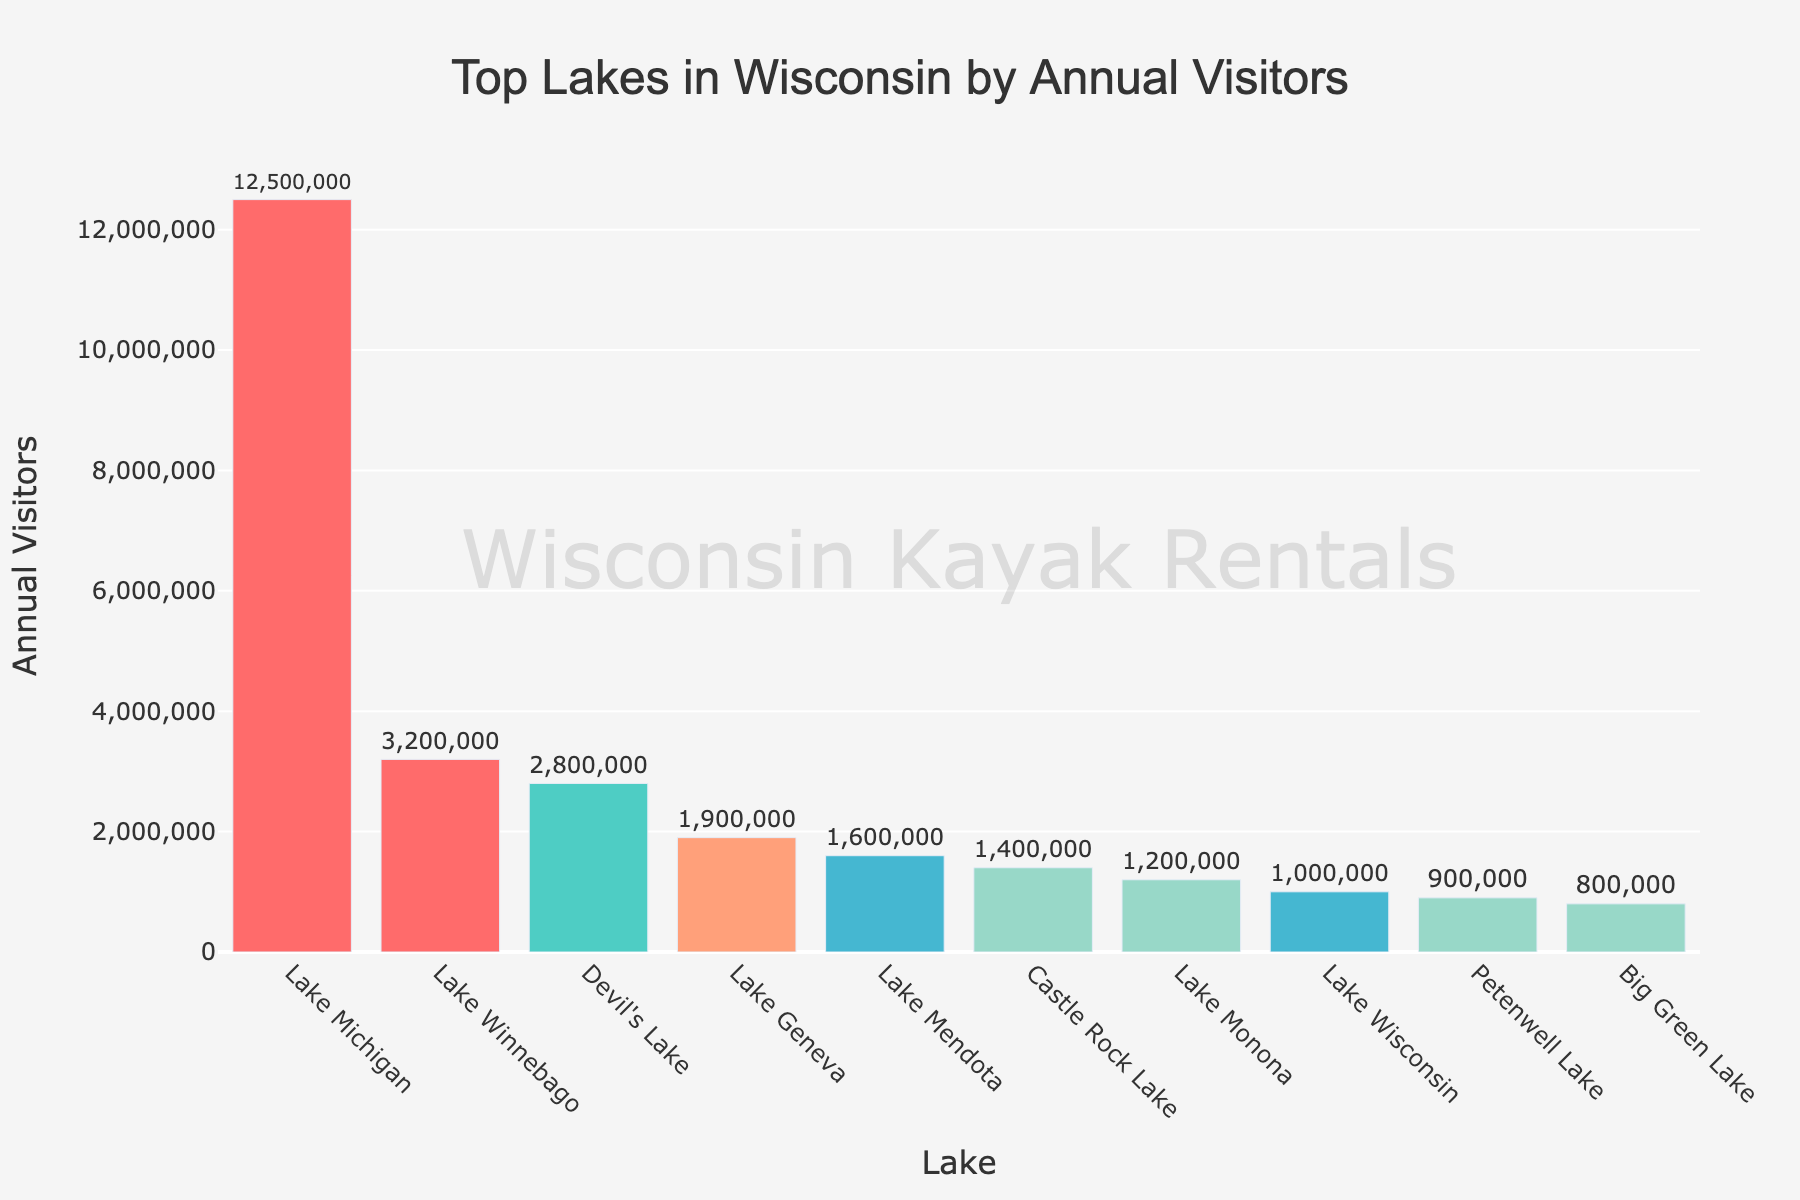Which lake has the highest number of annual visitors? The lake with the highest bar has the greatest number of annual visitors. From the figure, Lake Michigan has the highest bar.
Answer: Lake Michigan Which lake has fewer annual visitors, Lake Mendota or Lake Geneva? Compare the heights of the bars for Lake Mendota and Lake Geneva. Lake Mendota's bar is shorter than Lake Geneva's.
Answer: Lake Mendota What is the combined number of annual visitors for Devil's Lake and Castle Rock Lake? Add the visitor counts for Devil's Lake (2,800,000) and Castle Rock Lake (1,400,000). 2,800,000 + 1,400,000 = 4,200,000.
Answer: 4,200,000 How much more visitors does Lake Winnebago have than Lake Mendota? Subtract the annual visitors of Lake Mendota from Lake Winnebago. Lake Winnebago: 3,200,000, Lake Mendota: 1,600,000. 3,200,000 - 1,600,000 = 1,600,000.
Answer: 1,600,000 Which lake has just over 3 million visitors annually? Look for the bar with an annual visitor count slightly above 3 million. Lake Winnebago has 3,200,000 visitors.
Answer: Lake Winnebago How many visitors do the top three lakes have in total? Add the annual visitors of Lake Michigan, Lake Winnebago, and Devil's Lake. Lake Michigan: 12,500,000, Lake Winnebago: 3,200,000, Devil's Lake: 2,800,000. 12,500,000 + 3,200,000 + 2,800,000 = 18,500,000.
Answer: 18,500,000 Is the number of visitors to Lake Monona more or less than half of Lake Geneva's visitors? Calculate half of Lake Geneva's visitors: 1,900,000 / 2 = 950,000. Compare this with Lake Monona's visitors: 1,200,000. 1,200,000 is more than 950,000.
Answer: More Which lake with over 2 million visitors has the fewest visitors among them? Compare the lakes with above 2 million visitors: Lake Michigan, Lake Winnebago, and Devil's Lake. Devil's Lake has 2,800,000 visitors, which is the fewest among them.
Answer: Devil's Lake Among the lakes listed, which one has just slightly less than 1 million annual visitors? From the bars, Petenwell Lake has 900,000 visitors, slightly less than 1 million.
Answer: Petenwell Lake 